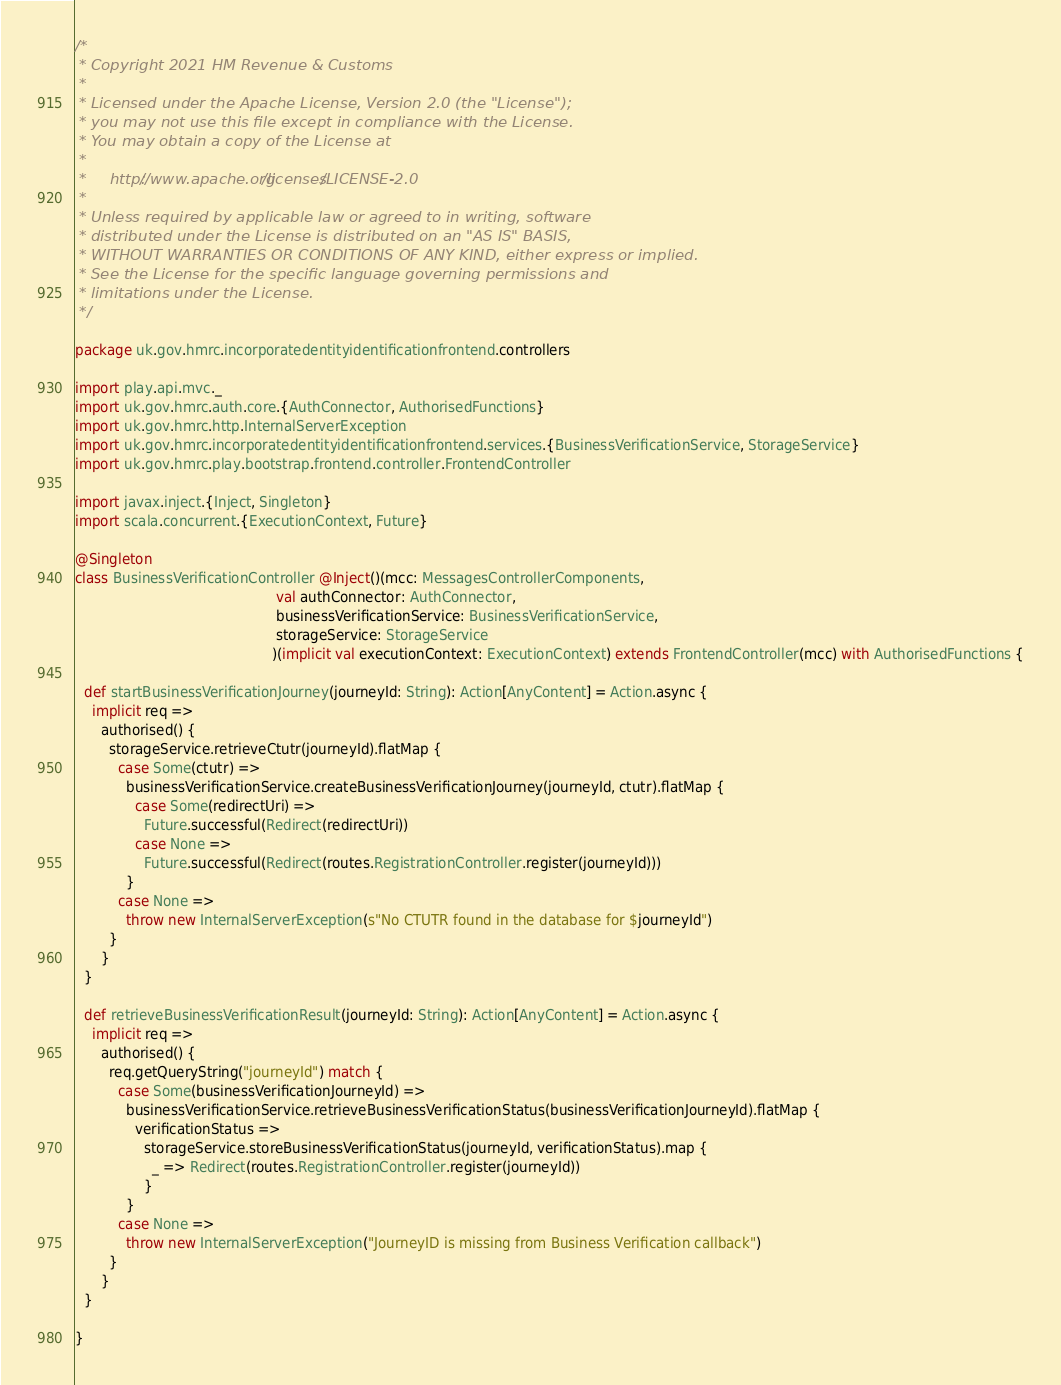Convert code to text. <code><loc_0><loc_0><loc_500><loc_500><_Scala_>/*
 * Copyright 2021 HM Revenue & Customs
 *
 * Licensed under the Apache License, Version 2.0 (the "License");
 * you may not use this file except in compliance with the License.
 * You may obtain a copy of the License at
 *
 *     http://www.apache.org/licenses/LICENSE-2.0
 *
 * Unless required by applicable law or agreed to in writing, software
 * distributed under the License is distributed on an "AS IS" BASIS,
 * WITHOUT WARRANTIES OR CONDITIONS OF ANY KIND, either express or implied.
 * See the License for the specific language governing permissions and
 * limitations under the License.
 */

package uk.gov.hmrc.incorporatedentityidentificationfrontend.controllers

import play.api.mvc._
import uk.gov.hmrc.auth.core.{AuthConnector, AuthorisedFunctions}
import uk.gov.hmrc.http.InternalServerException
import uk.gov.hmrc.incorporatedentityidentificationfrontend.services.{BusinessVerificationService, StorageService}
import uk.gov.hmrc.play.bootstrap.frontend.controller.FrontendController

import javax.inject.{Inject, Singleton}
import scala.concurrent.{ExecutionContext, Future}

@Singleton
class BusinessVerificationController @Inject()(mcc: MessagesControllerComponents,
                                               val authConnector: AuthConnector,
                                               businessVerificationService: BusinessVerificationService,
                                               storageService: StorageService
                                              )(implicit val executionContext: ExecutionContext) extends FrontendController(mcc) with AuthorisedFunctions {

  def startBusinessVerificationJourney(journeyId: String): Action[AnyContent] = Action.async {
    implicit req =>
      authorised() {
        storageService.retrieveCtutr(journeyId).flatMap {
          case Some(ctutr) =>
            businessVerificationService.createBusinessVerificationJourney(journeyId, ctutr).flatMap {
              case Some(redirectUri) =>
                Future.successful(Redirect(redirectUri))
              case None =>
                Future.successful(Redirect(routes.RegistrationController.register(journeyId)))
            }
          case None =>
            throw new InternalServerException(s"No CTUTR found in the database for $journeyId")
        }
      }
  }

  def retrieveBusinessVerificationResult(journeyId: String): Action[AnyContent] = Action.async {
    implicit req =>
      authorised() {
        req.getQueryString("journeyId") match {
          case Some(businessVerificationJourneyId) =>
            businessVerificationService.retrieveBusinessVerificationStatus(businessVerificationJourneyId).flatMap {
              verificationStatus =>
                storageService.storeBusinessVerificationStatus(journeyId, verificationStatus).map {
                  _ => Redirect(routes.RegistrationController.register(journeyId))
                }
            }
          case None =>
            throw new InternalServerException("JourneyID is missing from Business Verification callback")
        }
      }
  }

}</code> 